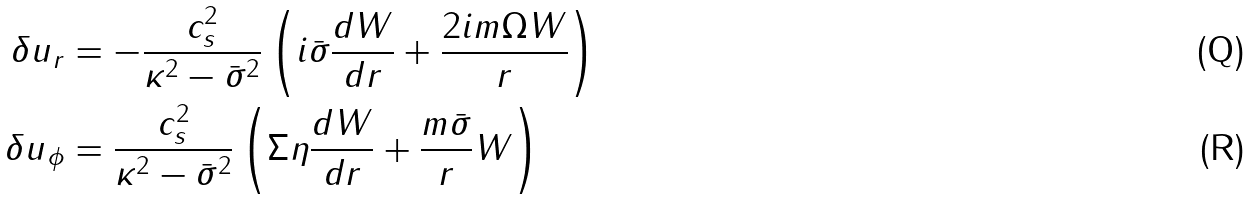Convert formula to latex. <formula><loc_0><loc_0><loc_500><loc_500>\delta u _ { r } & = - \frac { c _ { s } ^ { 2 } } { \kappa ^ { 2 } - \bar { \sigma } ^ { 2 } } \left ( i \bar { \sigma } \frac { d W } { d r } + \frac { 2 i m \Omega W } { r } \right ) \\ \delta u _ { \phi } & = \frac { c _ { s } ^ { 2 } } { \kappa ^ { 2 } - \bar { \sigma } ^ { 2 } } \left ( \Sigma \eta \frac { d W } { d r } + \frac { m \bar { \sigma } } { r } W \right )</formula> 